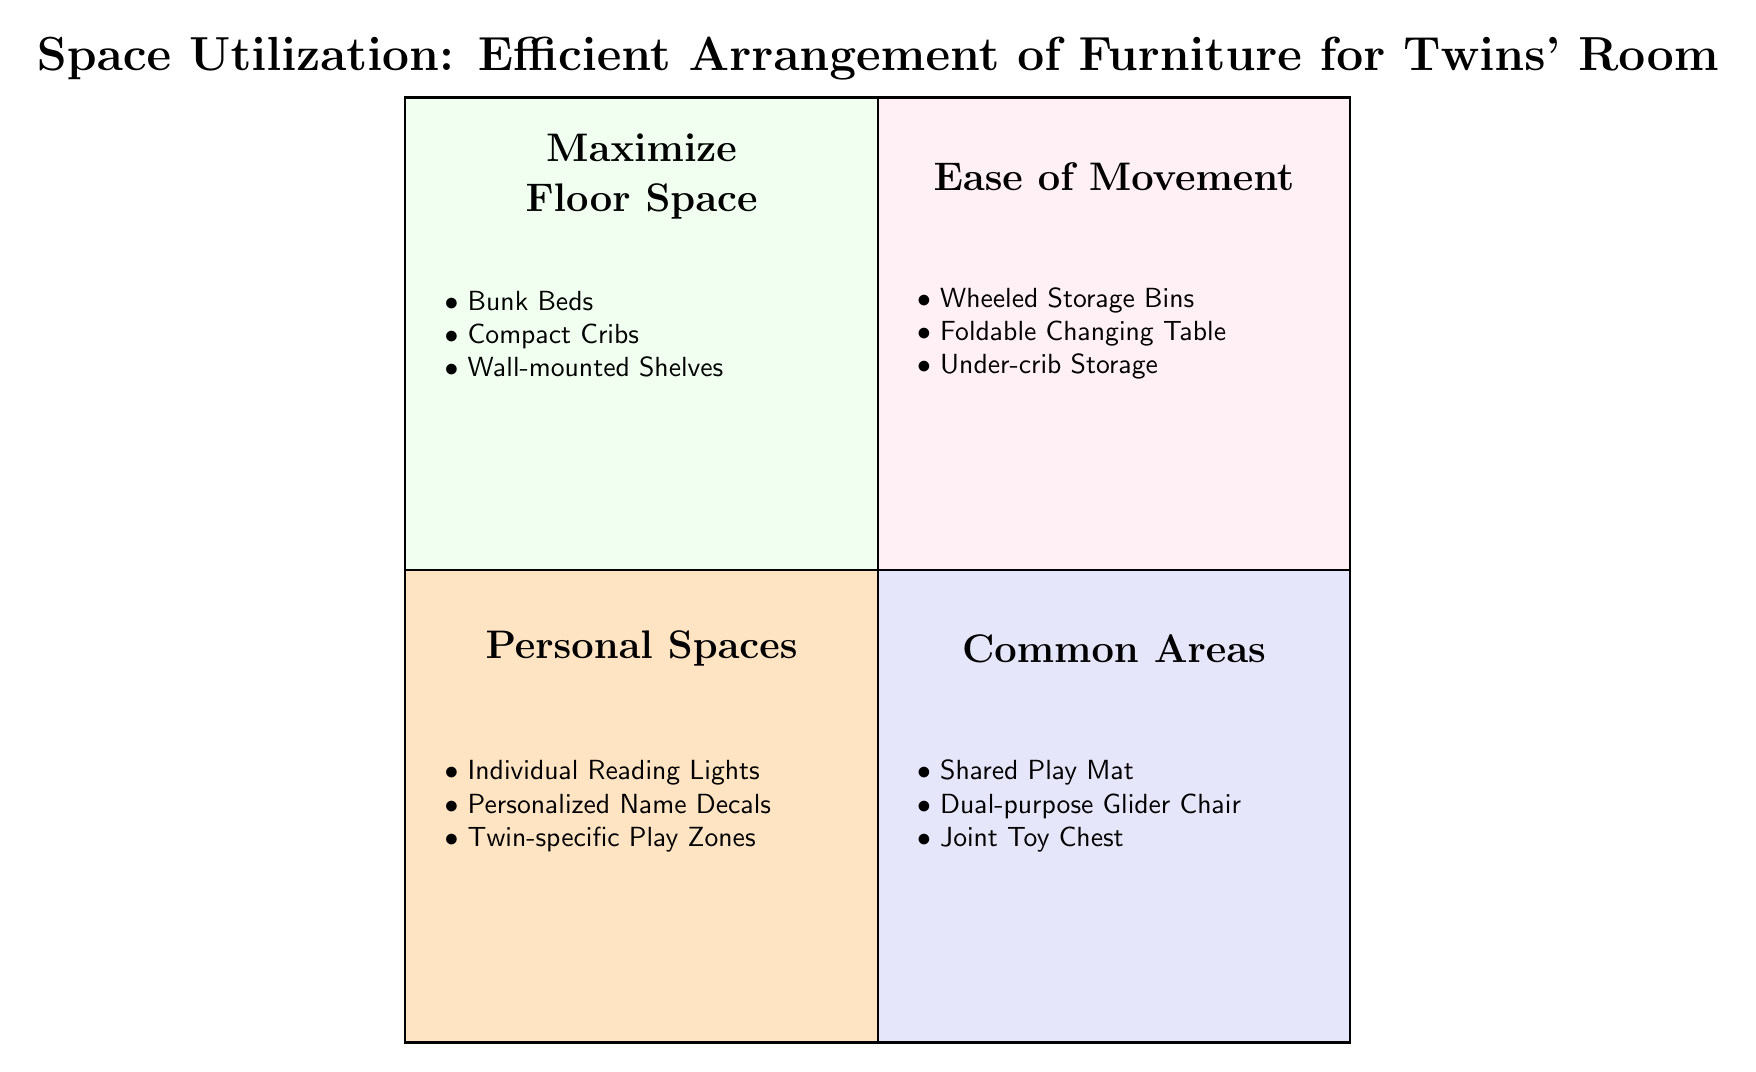What are the elements in Quadrant 1? Quadrant 1 is labeled "Maximize Floor Space" and contains three specific elements listed: Bunk Beds, Compact Cribs, and Wall-mounted Shelves
Answer: Bunk Beds, Compact Cribs, Wall-mounted Shelves How many elements are listed in Quadrant 3? Quadrant 3, titled "Personal Spaces," includes three elements: Individual Reading Lights, Personalized Name Decals, and Twin-specific Play Zones. Therefore, the total count of elements is three
Answer: 3 What is the primary focus of Quadrant 2? Quadrant 2 is titled "Ease of Movement," indicating that the focus in this area is on furniture arrangement that promotes mobility and accessibility in the room
Answer: Ease of Movement Which quadrant contains shared items for the twins? Quadrant 4, titled "Common Areas," is designed for shared items, including a Shared Play Mat, Dual-purpose Glider Chair, and Joint Toy Chest, indicating its focus on communal space
Answer: Common Areas Which element is mentioned in both Quadrant 3 and Quadrant 4? Upon reviewing the elements in both Quadrants 3 (Personal Spaces) and 4 (Common Areas), it can be established that none of the elements repeat; therefore, there are no shared elements between these quadrants
Answer: None What is the purpose of the Wheeled Storage Bins in Quadrant 2? The Wheeled Storage Bins' presence in Quadrant 2, labeled "Ease of Movement," implies that these are intended to facilitate easy transport and access to items, reducing clutter on the floor
Answer: Easy transport and access What is the color associated with Quadrant 1? Quadrant 1 is filled with a light beige color, which exemplifies its title "Maximize Floor Space" and visually distinguishes it from the other quadrants
Answer: Light beige How are the Personal Spaces differentiated from Common Areas? Quadrant 3 (Personal Spaces) focuses on individual items like reading lights and name decals personalizing each twin's area, while Quadrant 4 (Common Areas) emphasizes shared items that promote interaction between the twins, showcasing their differences in purpose
Answer: Individual vs. shared items 